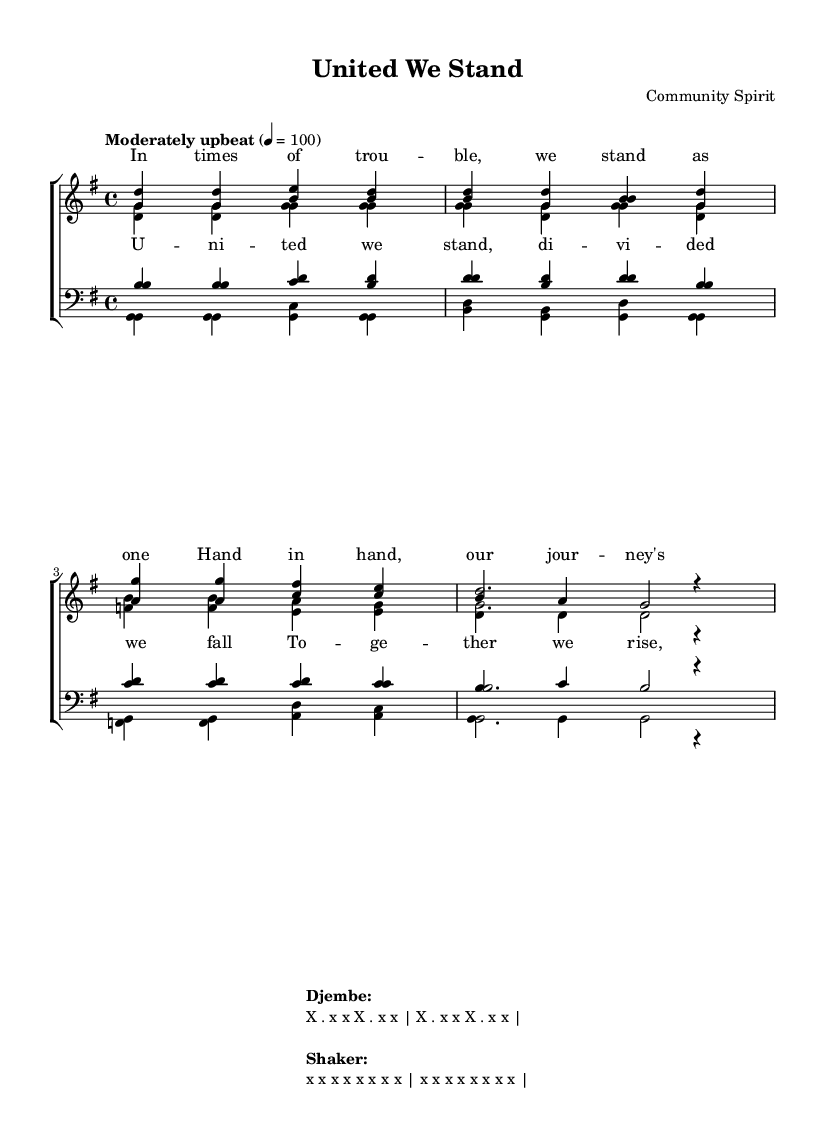What is the key signature of this music? The key signature is G major, indicated by one sharp (F#) which is the only sharp in the scale.
Answer: G major What is the time signature of this music? The time signature is 4/4, which is shown at the beginning of the score indicating four beats per measure.
Answer: 4/4 What is the tempo marking for the piece? The tempo is described as "Moderately upbeat" at a speed of 100 beats per minute, which indicates the desired speed of the music.
Answer: Moderately upbeat How many verses are there in the score? There are two verses, each with specific musical phrases for soprano, alto, tenor, and bass, identified clearly within the sections.
Answer: Two What is the primary theme of the lyrics? The lyrics focus on unity and resilience during difficult times, emphasizing collective strength and support within a community.
Answer: Unity and resilience Which instrument is associated with the rhythmic pattern described at the end? The rhythmic patterns described at the end of the score are for the djembe and shakers, indicating their role in creating the music's supportive rhythm.
Answer: Djembe and shaker 